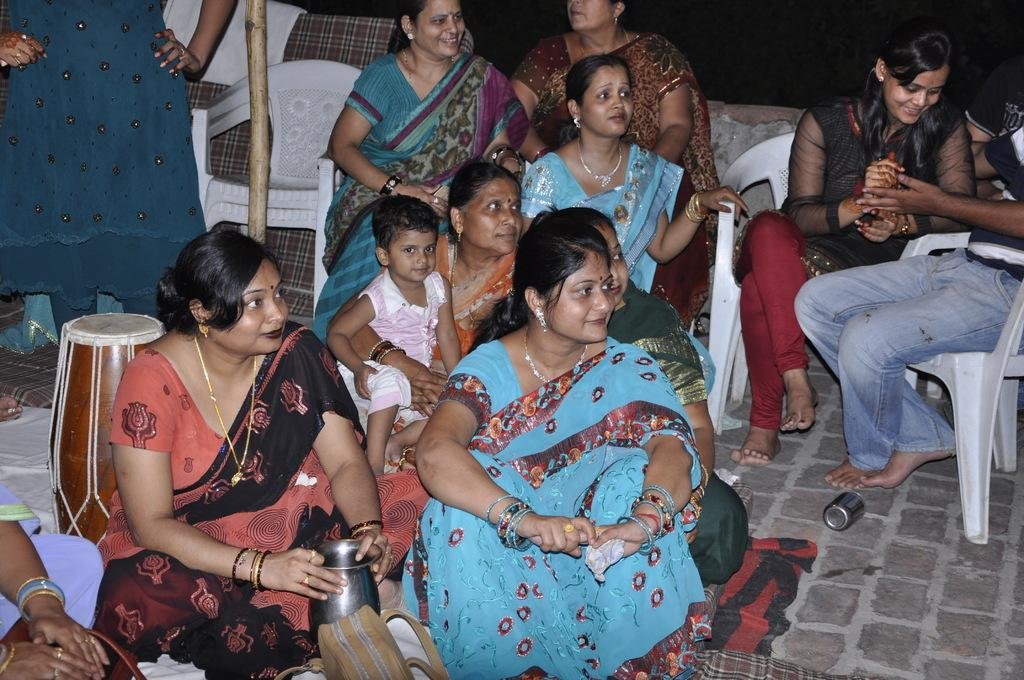How many people are in the image? There are several people in the image. What positions are the people in? Some people are sitting on chairs, while others are sitting on the floor. What can be seen on the left side of the image? There is a musical instrument on the left side of the image. What type of horn can be heard in the image? There is no horn present in the image, and therefore no sound can be heard. How does the pump affect the taste of the food in the image? There is no pump or food present in the image, so it is not possible to determine any effect on taste. 